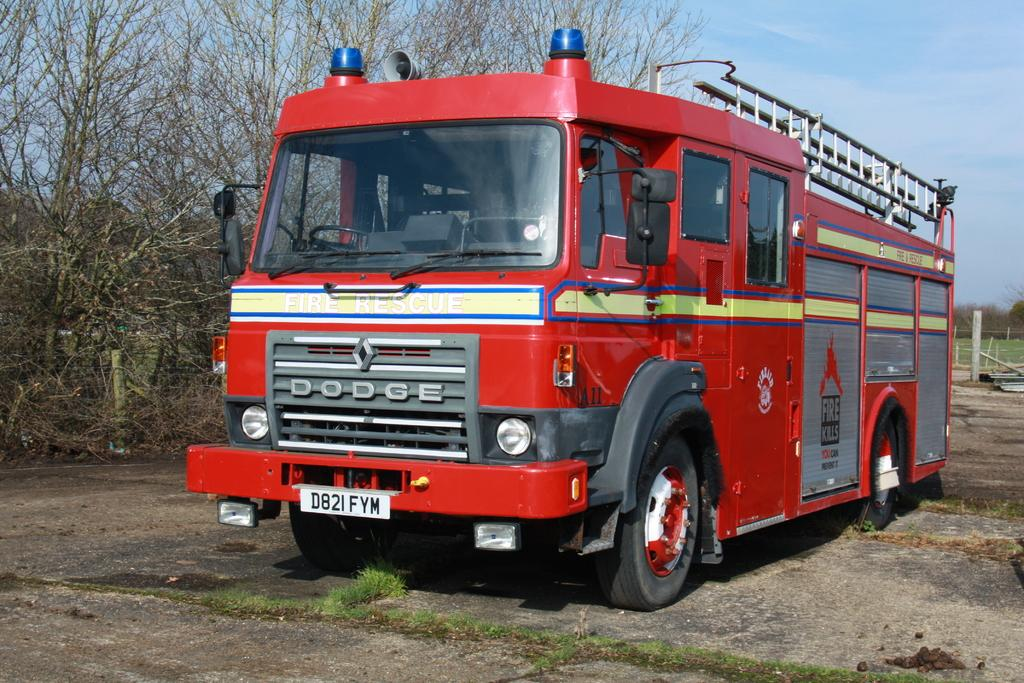What is the main subject of the image? The main subject of the image is a fire engine. What specific features does the fire engine have? The fire engine has revolving lights and a ladder at the top. What type of vegetation can be seen in the image? There are trees with branches in the image, and grass is also visible. What part of the natural environment is visible in the image? The sky is visible in the image. Can you tell me how many wounds are visible on the fire engine in the image? There are no wounds visible on the fire engine in the image. What type of cheese is being used to cover the ladder on the fire engine in the image? There is no cheese present in the image, and the ladder is not covered. 